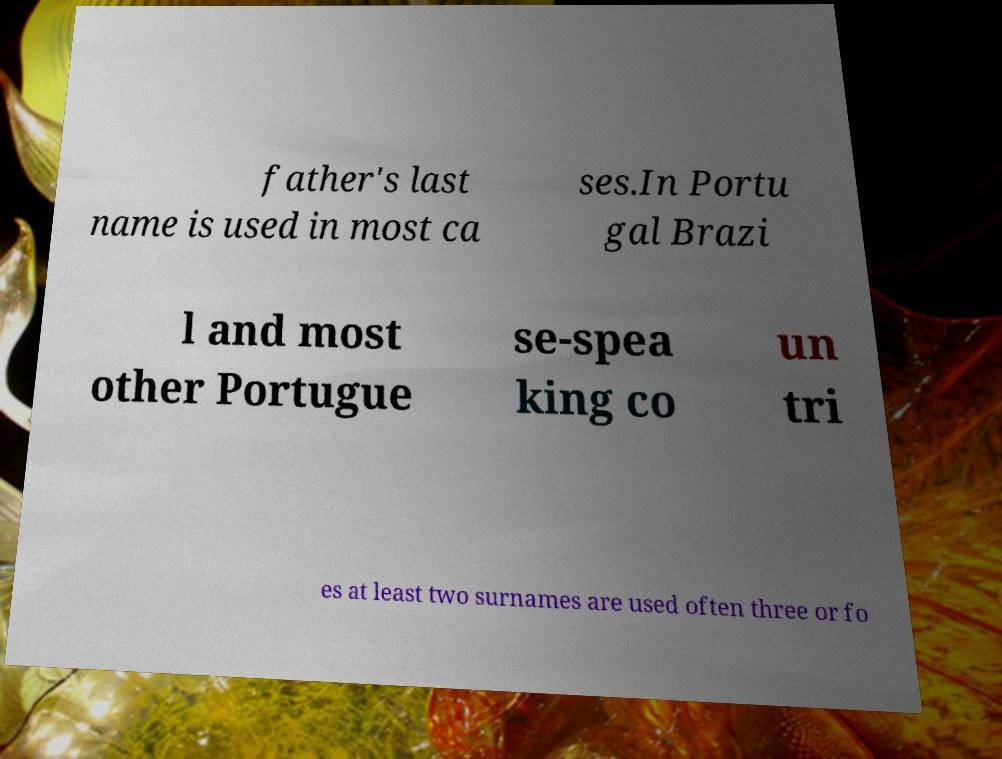Please identify and transcribe the text found in this image. father's last name is used in most ca ses.In Portu gal Brazi l and most other Portugue se-spea king co un tri es at least two surnames are used often three or fo 